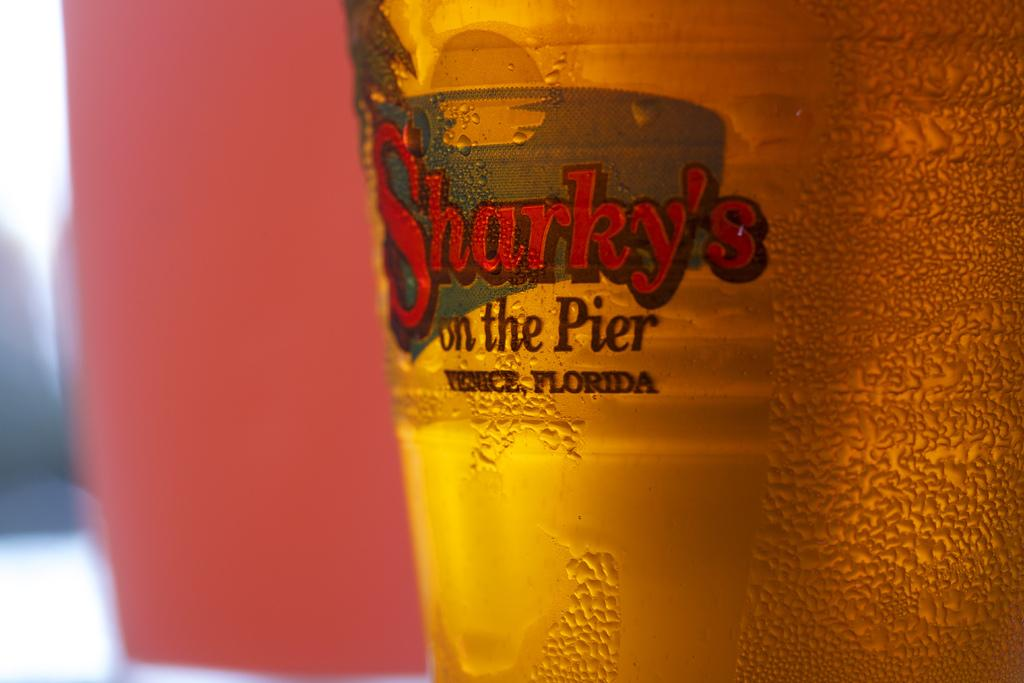What is in the bottle that is visible in the image? The bottle contains wine. What can be found on the bottle's exterior? There is a label on the bottle. What is written on the label? The label has the name "sparky" on it. Can you tell me how many cattle are visible in the image? There are no cattle present in the image; it features a bottle with a label. 